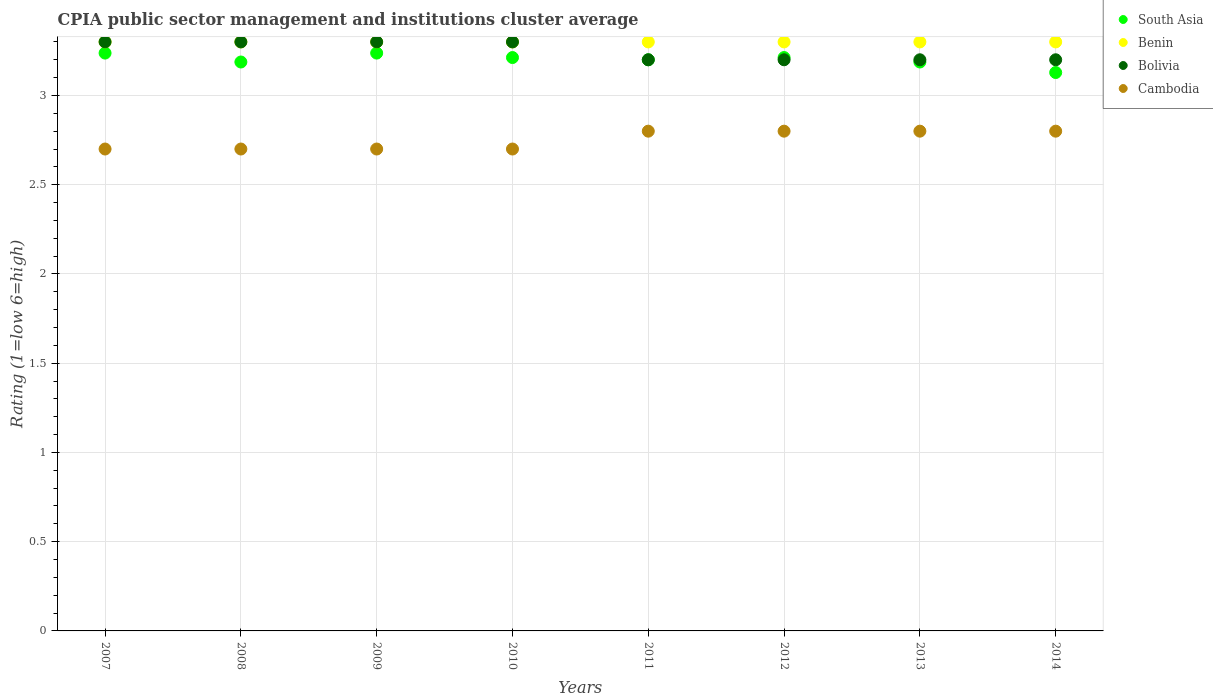How many different coloured dotlines are there?
Give a very brief answer. 4. Across all years, what is the minimum CPIA rating in Benin?
Offer a terse response. 3.3. What is the total CPIA rating in South Asia in the graph?
Give a very brief answer. 25.6. What is the difference between the CPIA rating in Bolivia in 2009 and that in 2012?
Your answer should be very brief. 0.1. What is the difference between the CPIA rating in Benin in 2009 and the CPIA rating in Cambodia in 2007?
Offer a very short reply. 0.6. What is the average CPIA rating in South Asia per year?
Ensure brevity in your answer.  3.2. In the year 2009, what is the difference between the CPIA rating in Cambodia and CPIA rating in South Asia?
Give a very brief answer. -0.54. In how many years, is the CPIA rating in Bolivia greater than 1.7?
Provide a short and direct response. 8. Is the difference between the CPIA rating in Cambodia in 2007 and 2010 greater than the difference between the CPIA rating in South Asia in 2007 and 2010?
Ensure brevity in your answer.  No. What is the difference between the highest and the second highest CPIA rating in South Asia?
Your response must be concise. 0. What is the difference between the highest and the lowest CPIA rating in Cambodia?
Give a very brief answer. 0.1. Is the CPIA rating in South Asia strictly greater than the CPIA rating in Bolivia over the years?
Offer a very short reply. No. Is the CPIA rating in Benin strictly less than the CPIA rating in Bolivia over the years?
Your answer should be very brief. No. How many years are there in the graph?
Provide a short and direct response. 8. Are the values on the major ticks of Y-axis written in scientific E-notation?
Ensure brevity in your answer.  No. Does the graph contain grids?
Your answer should be very brief. Yes. Where does the legend appear in the graph?
Offer a very short reply. Top right. What is the title of the graph?
Provide a succinct answer. CPIA public sector management and institutions cluster average. Does "Arab World" appear as one of the legend labels in the graph?
Your answer should be very brief. No. What is the label or title of the X-axis?
Keep it short and to the point. Years. What is the label or title of the Y-axis?
Your answer should be compact. Rating (1=low 6=high). What is the Rating (1=low 6=high) of South Asia in 2007?
Your answer should be very brief. 3.24. What is the Rating (1=low 6=high) of Bolivia in 2007?
Your response must be concise. 3.3. What is the Rating (1=low 6=high) of Cambodia in 2007?
Keep it short and to the point. 2.7. What is the Rating (1=low 6=high) in South Asia in 2008?
Ensure brevity in your answer.  3.19. What is the Rating (1=low 6=high) in Benin in 2008?
Your response must be concise. 3.3. What is the Rating (1=low 6=high) of South Asia in 2009?
Your response must be concise. 3.24. What is the Rating (1=low 6=high) of South Asia in 2010?
Keep it short and to the point. 3.21. What is the Rating (1=low 6=high) in Benin in 2010?
Make the answer very short. 3.3. What is the Rating (1=low 6=high) in Bolivia in 2010?
Your response must be concise. 3.3. What is the Rating (1=low 6=high) of Cambodia in 2010?
Provide a short and direct response. 2.7. What is the Rating (1=low 6=high) in South Asia in 2011?
Ensure brevity in your answer.  3.2. What is the Rating (1=low 6=high) of Benin in 2011?
Offer a very short reply. 3.3. What is the Rating (1=low 6=high) of Bolivia in 2011?
Provide a succinct answer. 3.2. What is the Rating (1=low 6=high) of South Asia in 2012?
Offer a terse response. 3.21. What is the Rating (1=low 6=high) in Cambodia in 2012?
Ensure brevity in your answer.  2.8. What is the Rating (1=low 6=high) of South Asia in 2013?
Your response must be concise. 3.19. What is the Rating (1=low 6=high) in Benin in 2013?
Ensure brevity in your answer.  3.3. What is the Rating (1=low 6=high) of Bolivia in 2013?
Keep it short and to the point. 3.2. What is the Rating (1=low 6=high) in Cambodia in 2013?
Your answer should be very brief. 2.8. What is the Rating (1=low 6=high) of South Asia in 2014?
Offer a terse response. 3.13. What is the Rating (1=low 6=high) of Benin in 2014?
Make the answer very short. 3.3. What is the Rating (1=low 6=high) of Bolivia in 2014?
Offer a terse response. 3.2. What is the Rating (1=low 6=high) of Cambodia in 2014?
Keep it short and to the point. 2.8. Across all years, what is the maximum Rating (1=low 6=high) of South Asia?
Your answer should be compact. 3.24. Across all years, what is the maximum Rating (1=low 6=high) in Bolivia?
Keep it short and to the point. 3.3. Across all years, what is the maximum Rating (1=low 6=high) in Cambodia?
Keep it short and to the point. 2.8. Across all years, what is the minimum Rating (1=low 6=high) of South Asia?
Your response must be concise. 3.13. Across all years, what is the minimum Rating (1=low 6=high) in Bolivia?
Your answer should be very brief. 3.2. What is the total Rating (1=low 6=high) in South Asia in the graph?
Give a very brief answer. 25.6. What is the total Rating (1=low 6=high) in Benin in the graph?
Give a very brief answer. 26.4. What is the total Rating (1=low 6=high) of Cambodia in the graph?
Your answer should be compact. 22. What is the difference between the Rating (1=low 6=high) in South Asia in 2007 and that in 2008?
Your response must be concise. 0.05. What is the difference between the Rating (1=low 6=high) in South Asia in 2007 and that in 2010?
Offer a very short reply. 0.03. What is the difference between the Rating (1=low 6=high) in Benin in 2007 and that in 2010?
Offer a very short reply. 0. What is the difference between the Rating (1=low 6=high) in South Asia in 2007 and that in 2011?
Your response must be concise. 0.04. What is the difference between the Rating (1=low 6=high) of Benin in 2007 and that in 2011?
Offer a very short reply. 0. What is the difference between the Rating (1=low 6=high) of Bolivia in 2007 and that in 2011?
Ensure brevity in your answer.  0.1. What is the difference between the Rating (1=low 6=high) in Cambodia in 2007 and that in 2011?
Your answer should be compact. -0.1. What is the difference between the Rating (1=low 6=high) in South Asia in 2007 and that in 2012?
Your answer should be compact. 0.03. What is the difference between the Rating (1=low 6=high) in Bolivia in 2007 and that in 2012?
Offer a very short reply. 0.1. What is the difference between the Rating (1=low 6=high) of South Asia in 2007 and that in 2013?
Your response must be concise. 0.05. What is the difference between the Rating (1=low 6=high) in Benin in 2007 and that in 2013?
Offer a very short reply. 0. What is the difference between the Rating (1=low 6=high) of Cambodia in 2007 and that in 2013?
Provide a succinct answer. -0.1. What is the difference between the Rating (1=low 6=high) of South Asia in 2007 and that in 2014?
Your answer should be very brief. 0.11. What is the difference between the Rating (1=low 6=high) in South Asia in 2008 and that in 2009?
Provide a short and direct response. -0.05. What is the difference between the Rating (1=low 6=high) of South Asia in 2008 and that in 2010?
Your response must be concise. -0.03. What is the difference between the Rating (1=low 6=high) in Benin in 2008 and that in 2010?
Provide a short and direct response. 0. What is the difference between the Rating (1=low 6=high) of Bolivia in 2008 and that in 2010?
Offer a terse response. 0. What is the difference between the Rating (1=low 6=high) of Cambodia in 2008 and that in 2010?
Offer a very short reply. 0. What is the difference between the Rating (1=low 6=high) in South Asia in 2008 and that in 2011?
Give a very brief answer. -0.01. What is the difference between the Rating (1=low 6=high) in Bolivia in 2008 and that in 2011?
Ensure brevity in your answer.  0.1. What is the difference between the Rating (1=low 6=high) in Cambodia in 2008 and that in 2011?
Your answer should be very brief. -0.1. What is the difference between the Rating (1=low 6=high) of South Asia in 2008 and that in 2012?
Provide a succinct answer. -0.03. What is the difference between the Rating (1=low 6=high) of Benin in 2008 and that in 2012?
Make the answer very short. 0. What is the difference between the Rating (1=low 6=high) of Bolivia in 2008 and that in 2012?
Make the answer very short. 0.1. What is the difference between the Rating (1=low 6=high) of Cambodia in 2008 and that in 2012?
Offer a very short reply. -0.1. What is the difference between the Rating (1=low 6=high) in South Asia in 2008 and that in 2013?
Your answer should be very brief. 0. What is the difference between the Rating (1=low 6=high) in Benin in 2008 and that in 2013?
Your response must be concise. 0. What is the difference between the Rating (1=low 6=high) of Bolivia in 2008 and that in 2013?
Your answer should be very brief. 0.1. What is the difference between the Rating (1=low 6=high) in Cambodia in 2008 and that in 2013?
Give a very brief answer. -0.1. What is the difference between the Rating (1=low 6=high) in South Asia in 2008 and that in 2014?
Make the answer very short. 0.06. What is the difference between the Rating (1=low 6=high) in South Asia in 2009 and that in 2010?
Offer a terse response. 0.03. What is the difference between the Rating (1=low 6=high) of Bolivia in 2009 and that in 2010?
Your response must be concise. 0. What is the difference between the Rating (1=low 6=high) of Cambodia in 2009 and that in 2010?
Ensure brevity in your answer.  0. What is the difference between the Rating (1=low 6=high) of South Asia in 2009 and that in 2011?
Offer a very short reply. 0.04. What is the difference between the Rating (1=low 6=high) of Bolivia in 2009 and that in 2011?
Your answer should be compact. 0.1. What is the difference between the Rating (1=low 6=high) in South Asia in 2009 and that in 2012?
Make the answer very short. 0.03. What is the difference between the Rating (1=low 6=high) of Bolivia in 2009 and that in 2012?
Offer a very short reply. 0.1. What is the difference between the Rating (1=low 6=high) in South Asia in 2009 and that in 2013?
Your answer should be very brief. 0.05. What is the difference between the Rating (1=low 6=high) in Bolivia in 2009 and that in 2013?
Provide a short and direct response. 0.1. What is the difference between the Rating (1=low 6=high) in South Asia in 2009 and that in 2014?
Keep it short and to the point. 0.11. What is the difference between the Rating (1=low 6=high) of Benin in 2009 and that in 2014?
Provide a succinct answer. 0. What is the difference between the Rating (1=low 6=high) of Bolivia in 2009 and that in 2014?
Ensure brevity in your answer.  0.1. What is the difference between the Rating (1=low 6=high) in Cambodia in 2009 and that in 2014?
Offer a terse response. -0.1. What is the difference between the Rating (1=low 6=high) of South Asia in 2010 and that in 2011?
Make the answer very short. 0.01. What is the difference between the Rating (1=low 6=high) of Benin in 2010 and that in 2011?
Offer a very short reply. 0. What is the difference between the Rating (1=low 6=high) in Cambodia in 2010 and that in 2011?
Provide a short and direct response. -0.1. What is the difference between the Rating (1=low 6=high) in South Asia in 2010 and that in 2012?
Provide a short and direct response. 0. What is the difference between the Rating (1=low 6=high) of Cambodia in 2010 and that in 2012?
Your answer should be very brief. -0.1. What is the difference between the Rating (1=low 6=high) of South Asia in 2010 and that in 2013?
Provide a short and direct response. 0.03. What is the difference between the Rating (1=low 6=high) of Bolivia in 2010 and that in 2013?
Provide a short and direct response. 0.1. What is the difference between the Rating (1=low 6=high) of Cambodia in 2010 and that in 2013?
Ensure brevity in your answer.  -0.1. What is the difference between the Rating (1=low 6=high) in South Asia in 2010 and that in 2014?
Offer a very short reply. 0.08. What is the difference between the Rating (1=low 6=high) in Benin in 2010 and that in 2014?
Your answer should be compact. 0. What is the difference between the Rating (1=low 6=high) in Bolivia in 2010 and that in 2014?
Provide a succinct answer. 0.1. What is the difference between the Rating (1=low 6=high) of Cambodia in 2010 and that in 2014?
Your answer should be very brief. -0.1. What is the difference between the Rating (1=low 6=high) in South Asia in 2011 and that in 2012?
Offer a terse response. -0.01. What is the difference between the Rating (1=low 6=high) of Benin in 2011 and that in 2012?
Keep it short and to the point. 0. What is the difference between the Rating (1=low 6=high) of South Asia in 2011 and that in 2013?
Keep it short and to the point. 0.01. What is the difference between the Rating (1=low 6=high) of Cambodia in 2011 and that in 2013?
Keep it short and to the point. 0. What is the difference between the Rating (1=low 6=high) in South Asia in 2011 and that in 2014?
Your answer should be very brief. 0.07. What is the difference between the Rating (1=low 6=high) of Bolivia in 2011 and that in 2014?
Give a very brief answer. 0. What is the difference between the Rating (1=low 6=high) in Cambodia in 2011 and that in 2014?
Provide a short and direct response. 0. What is the difference between the Rating (1=low 6=high) in South Asia in 2012 and that in 2013?
Your answer should be compact. 0.03. What is the difference between the Rating (1=low 6=high) of Bolivia in 2012 and that in 2013?
Provide a succinct answer. 0. What is the difference between the Rating (1=low 6=high) in South Asia in 2012 and that in 2014?
Your answer should be compact. 0.08. What is the difference between the Rating (1=low 6=high) in South Asia in 2013 and that in 2014?
Give a very brief answer. 0.06. What is the difference between the Rating (1=low 6=high) in Benin in 2013 and that in 2014?
Offer a very short reply. 0. What is the difference between the Rating (1=low 6=high) in Cambodia in 2013 and that in 2014?
Ensure brevity in your answer.  0. What is the difference between the Rating (1=low 6=high) in South Asia in 2007 and the Rating (1=low 6=high) in Benin in 2008?
Your answer should be compact. -0.06. What is the difference between the Rating (1=low 6=high) in South Asia in 2007 and the Rating (1=low 6=high) in Bolivia in 2008?
Your answer should be compact. -0.06. What is the difference between the Rating (1=low 6=high) of South Asia in 2007 and the Rating (1=low 6=high) of Cambodia in 2008?
Your answer should be compact. 0.54. What is the difference between the Rating (1=low 6=high) of Benin in 2007 and the Rating (1=low 6=high) of Cambodia in 2008?
Your answer should be very brief. 0.6. What is the difference between the Rating (1=low 6=high) in South Asia in 2007 and the Rating (1=low 6=high) in Benin in 2009?
Give a very brief answer. -0.06. What is the difference between the Rating (1=low 6=high) of South Asia in 2007 and the Rating (1=low 6=high) of Bolivia in 2009?
Provide a short and direct response. -0.06. What is the difference between the Rating (1=low 6=high) of South Asia in 2007 and the Rating (1=low 6=high) of Cambodia in 2009?
Offer a very short reply. 0.54. What is the difference between the Rating (1=low 6=high) in South Asia in 2007 and the Rating (1=low 6=high) in Benin in 2010?
Provide a succinct answer. -0.06. What is the difference between the Rating (1=low 6=high) in South Asia in 2007 and the Rating (1=low 6=high) in Bolivia in 2010?
Provide a succinct answer. -0.06. What is the difference between the Rating (1=low 6=high) in South Asia in 2007 and the Rating (1=low 6=high) in Cambodia in 2010?
Your response must be concise. 0.54. What is the difference between the Rating (1=low 6=high) of Benin in 2007 and the Rating (1=low 6=high) of Cambodia in 2010?
Offer a terse response. 0.6. What is the difference between the Rating (1=low 6=high) of South Asia in 2007 and the Rating (1=low 6=high) of Benin in 2011?
Your answer should be compact. -0.06. What is the difference between the Rating (1=low 6=high) of South Asia in 2007 and the Rating (1=low 6=high) of Bolivia in 2011?
Offer a very short reply. 0.04. What is the difference between the Rating (1=low 6=high) of South Asia in 2007 and the Rating (1=low 6=high) of Cambodia in 2011?
Make the answer very short. 0.44. What is the difference between the Rating (1=low 6=high) in Bolivia in 2007 and the Rating (1=low 6=high) in Cambodia in 2011?
Provide a short and direct response. 0.5. What is the difference between the Rating (1=low 6=high) in South Asia in 2007 and the Rating (1=low 6=high) in Benin in 2012?
Offer a very short reply. -0.06. What is the difference between the Rating (1=low 6=high) in South Asia in 2007 and the Rating (1=low 6=high) in Bolivia in 2012?
Your response must be concise. 0.04. What is the difference between the Rating (1=low 6=high) in South Asia in 2007 and the Rating (1=low 6=high) in Cambodia in 2012?
Offer a terse response. 0.44. What is the difference between the Rating (1=low 6=high) of Benin in 2007 and the Rating (1=low 6=high) of Bolivia in 2012?
Ensure brevity in your answer.  0.1. What is the difference between the Rating (1=low 6=high) in Bolivia in 2007 and the Rating (1=low 6=high) in Cambodia in 2012?
Offer a terse response. 0.5. What is the difference between the Rating (1=low 6=high) in South Asia in 2007 and the Rating (1=low 6=high) in Benin in 2013?
Keep it short and to the point. -0.06. What is the difference between the Rating (1=low 6=high) in South Asia in 2007 and the Rating (1=low 6=high) in Bolivia in 2013?
Offer a terse response. 0.04. What is the difference between the Rating (1=low 6=high) in South Asia in 2007 and the Rating (1=low 6=high) in Cambodia in 2013?
Ensure brevity in your answer.  0.44. What is the difference between the Rating (1=low 6=high) of Benin in 2007 and the Rating (1=low 6=high) of Bolivia in 2013?
Your answer should be compact. 0.1. What is the difference between the Rating (1=low 6=high) of South Asia in 2007 and the Rating (1=low 6=high) of Benin in 2014?
Offer a terse response. -0.06. What is the difference between the Rating (1=low 6=high) of South Asia in 2007 and the Rating (1=low 6=high) of Bolivia in 2014?
Offer a terse response. 0.04. What is the difference between the Rating (1=low 6=high) in South Asia in 2007 and the Rating (1=low 6=high) in Cambodia in 2014?
Ensure brevity in your answer.  0.44. What is the difference between the Rating (1=low 6=high) of Benin in 2007 and the Rating (1=low 6=high) of Bolivia in 2014?
Ensure brevity in your answer.  0.1. What is the difference between the Rating (1=low 6=high) of South Asia in 2008 and the Rating (1=low 6=high) of Benin in 2009?
Provide a short and direct response. -0.11. What is the difference between the Rating (1=low 6=high) of South Asia in 2008 and the Rating (1=low 6=high) of Bolivia in 2009?
Provide a short and direct response. -0.11. What is the difference between the Rating (1=low 6=high) of South Asia in 2008 and the Rating (1=low 6=high) of Cambodia in 2009?
Offer a very short reply. 0.49. What is the difference between the Rating (1=low 6=high) of Bolivia in 2008 and the Rating (1=low 6=high) of Cambodia in 2009?
Offer a very short reply. 0.6. What is the difference between the Rating (1=low 6=high) in South Asia in 2008 and the Rating (1=low 6=high) in Benin in 2010?
Make the answer very short. -0.11. What is the difference between the Rating (1=low 6=high) of South Asia in 2008 and the Rating (1=low 6=high) of Bolivia in 2010?
Make the answer very short. -0.11. What is the difference between the Rating (1=low 6=high) of South Asia in 2008 and the Rating (1=low 6=high) of Cambodia in 2010?
Your response must be concise. 0.49. What is the difference between the Rating (1=low 6=high) in Benin in 2008 and the Rating (1=low 6=high) in Cambodia in 2010?
Keep it short and to the point. 0.6. What is the difference between the Rating (1=low 6=high) in Bolivia in 2008 and the Rating (1=low 6=high) in Cambodia in 2010?
Provide a short and direct response. 0.6. What is the difference between the Rating (1=low 6=high) in South Asia in 2008 and the Rating (1=low 6=high) in Benin in 2011?
Offer a terse response. -0.11. What is the difference between the Rating (1=low 6=high) of South Asia in 2008 and the Rating (1=low 6=high) of Bolivia in 2011?
Offer a terse response. -0.01. What is the difference between the Rating (1=low 6=high) of South Asia in 2008 and the Rating (1=low 6=high) of Cambodia in 2011?
Provide a succinct answer. 0.39. What is the difference between the Rating (1=low 6=high) in Benin in 2008 and the Rating (1=low 6=high) in Cambodia in 2011?
Give a very brief answer. 0.5. What is the difference between the Rating (1=low 6=high) of South Asia in 2008 and the Rating (1=low 6=high) of Benin in 2012?
Make the answer very short. -0.11. What is the difference between the Rating (1=low 6=high) in South Asia in 2008 and the Rating (1=low 6=high) in Bolivia in 2012?
Your response must be concise. -0.01. What is the difference between the Rating (1=low 6=high) of South Asia in 2008 and the Rating (1=low 6=high) of Cambodia in 2012?
Keep it short and to the point. 0.39. What is the difference between the Rating (1=low 6=high) of South Asia in 2008 and the Rating (1=low 6=high) of Benin in 2013?
Provide a succinct answer. -0.11. What is the difference between the Rating (1=low 6=high) in South Asia in 2008 and the Rating (1=low 6=high) in Bolivia in 2013?
Provide a succinct answer. -0.01. What is the difference between the Rating (1=low 6=high) in South Asia in 2008 and the Rating (1=low 6=high) in Cambodia in 2013?
Offer a terse response. 0.39. What is the difference between the Rating (1=low 6=high) of Benin in 2008 and the Rating (1=low 6=high) of Bolivia in 2013?
Give a very brief answer. 0.1. What is the difference between the Rating (1=low 6=high) in Benin in 2008 and the Rating (1=low 6=high) in Cambodia in 2013?
Offer a terse response. 0.5. What is the difference between the Rating (1=low 6=high) of South Asia in 2008 and the Rating (1=low 6=high) of Benin in 2014?
Offer a terse response. -0.11. What is the difference between the Rating (1=low 6=high) of South Asia in 2008 and the Rating (1=low 6=high) of Bolivia in 2014?
Your answer should be very brief. -0.01. What is the difference between the Rating (1=low 6=high) in South Asia in 2008 and the Rating (1=low 6=high) in Cambodia in 2014?
Offer a very short reply. 0.39. What is the difference between the Rating (1=low 6=high) of Benin in 2008 and the Rating (1=low 6=high) of Bolivia in 2014?
Your response must be concise. 0.1. What is the difference between the Rating (1=low 6=high) of Benin in 2008 and the Rating (1=low 6=high) of Cambodia in 2014?
Your response must be concise. 0.5. What is the difference between the Rating (1=low 6=high) of Bolivia in 2008 and the Rating (1=low 6=high) of Cambodia in 2014?
Provide a short and direct response. 0.5. What is the difference between the Rating (1=low 6=high) of South Asia in 2009 and the Rating (1=low 6=high) of Benin in 2010?
Give a very brief answer. -0.06. What is the difference between the Rating (1=low 6=high) of South Asia in 2009 and the Rating (1=low 6=high) of Bolivia in 2010?
Make the answer very short. -0.06. What is the difference between the Rating (1=low 6=high) in South Asia in 2009 and the Rating (1=low 6=high) in Cambodia in 2010?
Offer a very short reply. 0.54. What is the difference between the Rating (1=low 6=high) of Benin in 2009 and the Rating (1=low 6=high) of Cambodia in 2010?
Provide a succinct answer. 0.6. What is the difference between the Rating (1=low 6=high) in Bolivia in 2009 and the Rating (1=low 6=high) in Cambodia in 2010?
Ensure brevity in your answer.  0.6. What is the difference between the Rating (1=low 6=high) in South Asia in 2009 and the Rating (1=low 6=high) in Benin in 2011?
Your answer should be very brief. -0.06. What is the difference between the Rating (1=low 6=high) in South Asia in 2009 and the Rating (1=low 6=high) in Bolivia in 2011?
Keep it short and to the point. 0.04. What is the difference between the Rating (1=low 6=high) of South Asia in 2009 and the Rating (1=low 6=high) of Cambodia in 2011?
Offer a terse response. 0.44. What is the difference between the Rating (1=low 6=high) of South Asia in 2009 and the Rating (1=low 6=high) of Benin in 2012?
Your response must be concise. -0.06. What is the difference between the Rating (1=low 6=high) of South Asia in 2009 and the Rating (1=low 6=high) of Bolivia in 2012?
Offer a terse response. 0.04. What is the difference between the Rating (1=low 6=high) in South Asia in 2009 and the Rating (1=low 6=high) in Cambodia in 2012?
Give a very brief answer. 0.44. What is the difference between the Rating (1=low 6=high) in South Asia in 2009 and the Rating (1=low 6=high) in Benin in 2013?
Offer a very short reply. -0.06. What is the difference between the Rating (1=low 6=high) of South Asia in 2009 and the Rating (1=low 6=high) of Bolivia in 2013?
Provide a short and direct response. 0.04. What is the difference between the Rating (1=low 6=high) of South Asia in 2009 and the Rating (1=low 6=high) of Cambodia in 2013?
Ensure brevity in your answer.  0.44. What is the difference between the Rating (1=low 6=high) in Benin in 2009 and the Rating (1=low 6=high) in Cambodia in 2013?
Offer a very short reply. 0.5. What is the difference between the Rating (1=low 6=high) of Bolivia in 2009 and the Rating (1=low 6=high) of Cambodia in 2013?
Keep it short and to the point. 0.5. What is the difference between the Rating (1=low 6=high) of South Asia in 2009 and the Rating (1=low 6=high) of Benin in 2014?
Your answer should be compact. -0.06. What is the difference between the Rating (1=low 6=high) in South Asia in 2009 and the Rating (1=low 6=high) in Bolivia in 2014?
Keep it short and to the point. 0.04. What is the difference between the Rating (1=low 6=high) of South Asia in 2009 and the Rating (1=low 6=high) of Cambodia in 2014?
Your answer should be compact. 0.44. What is the difference between the Rating (1=low 6=high) in Bolivia in 2009 and the Rating (1=low 6=high) in Cambodia in 2014?
Provide a short and direct response. 0.5. What is the difference between the Rating (1=low 6=high) in South Asia in 2010 and the Rating (1=low 6=high) in Benin in 2011?
Offer a terse response. -0.09. What is the difference between the Rating (1=low 6=high) of South Asia in 2010 and the Rating (1=low 6=high) of Bolivia in 2011?
Keep it short and to the point. 0.01. What is the difference between the Rating (1=low 6=high) of South Asia in 2010 and the Rating (1=low 6=high) of Cambodia in 2011?
Your answer should be very brief. 0.41. What is the difference between the Rating (1=low 6=high) of Benin in 2010 and the Rating (1=low 6=high) of Bolivia in 2011?
Give a very brief answer. 0.1. What is the difference between the Rating (1=low 6=high) of Bolivia in 2010 and the Rating (1=low 6=high) of Cambodia in 2011?
Your answer should be compact. 0.5. What is the difference between the Rating (1=low 6=high) of South Asia in 2010 and the Rating (1=low 6=high) of Benin in 2012?
Offer a terse response. -0.09. What is the difference between the Rating (1=low 6=high) in South Asia in 2010 and the Rating (1=low 6=high) in Bolivia in 2012?
Your answer should be compact. 0.01. What is the difference between the Rating (1=low 6=high) in South Asia in 2010 and the Rating (1=low 6=high) in Cambodia in 2012?
Provide a succinct answer. 0.41. What is the difference between the Rating (1=low 6=high) in Bolivia in 2010 and the Rating (1=low 6=high) in Cambodia in 2012?
Your answer should be very brief. 0.5. What is the difference between the Rating (1=low 6=high) in South Asia in 2010 and the Rating (1=low 6=high) in Benin in 2013?
Ensure brevity in your answer.  -0.09. What is the difference between the Rating (1=low 6=high) of South Asia in 2010 and the Rating (1=low 6=high) of Bolivia in 2013?
Your answer should be compact. 0.01. What is the difference between the Rating (1=low 6=high) of South Asia in 2010 and the Rating (1=low 6=high) of Cambodia in 2013?
Provide a short and direct response. 0.41. What is the difference between the Rating (1=low 6=high) in Benin in 2010 and the Rating (1=low 6=high) in Bolivia in 2013?
Ensure brevity in your answer.  0.1. What is the difference between the Rating (1=low 6=high) in Benin in 2010 and the Rating (1=low 6=high) in Cambodia in 2013?
Your response must be concise. 0.5. What is the difference between the Rating (1=low 6=high) of South Asia in 2010 and the Rating (1=low 6=high) of Benin in 2014?
Give a very brief answer. -0.09. What is the difference between the Rating (1=low 6=high) in South Asia in 2010 and the Rating (1=low 6=high) in Bolivia in 2014?
Your answer should be compact. 0.01. What is the difference between the Rating (1=low 6=high) in South Asia in 2010 and the Rating (1=low 6=high) in Cambodia in 2014?
Your answer should be compact. 0.41. What is the difference between the Rating (1=low 6=high) in Benin in 2010 and the Rating (1=low 6=high) in Cambodia in 2014?
Offer a terse response. 0.5. What is the difference between the Rating (1=low 6=high) in Bolivia in 2010 and the Rating (1=low 6=high) in Cambodia in 2014?
Offer a very short reply. 0.5. What is the difference between the Rating (1=low 6=high) in South Asia in 2011 and the Rating (1=low 6=high) in Benin in 2012?
Offer a terse response. -0.1. What is the difference between the Rating (1=low 6=high) of South Asia in 2011 and the Rating (1=low 6=high) of Bolivia in 2012?
Your response must be concise. 0. What is the difference between the Rating (1=low 6=high) of Benin in 2011 and the Rating (1=low 6=high) of Cambodia in 2012?
Your response must be concise. 0.5. What is the difference between the Rating (1=low 6=high) of Bolivia in 2011 and the Rating (1=low 6=high) of Cambodia in 2012?
Offer a very short reply. 0.4. What is the difference between the Rating (1=low 6=high) of South Asia in 2011 and the Rating (1=low 6=high) of Benin in 2013?
Your response must be concise. -0.1. What is the difference between the Rating (1=low 6=high) in South Asia in 2011 and the Rating (1=low 6=high) in Bolivia in 2013?
Ensure brevity in your answer.  0. What is the difference between the Rating (1=low 6=high) in South Asia in 2011 and the Rating (1=low 6=high) in Cambodia in 2013?
Make the answer very short. 0.4. What is the difference between the Rating (1=low 6=high) of Benin in 2011 and the Rating (1=low 6=high) of Bolivia in 2013?
Your answer should be very brief. 0.1. What is the difference between the Rating (1=low 6=high) in South Asia in 2011 and the Rating (1=low 6=high) in Benin in 2014?
Give a very brief answer. -0.1. What is the difference between the Rating (1=low 6=high) in South Asia in 2011 and the Rating (1=low 6=high) in Bolivia in 2014?
Give a very brief answer. 0. What is the difference between the Rating (1=low 6=high) in Benin in 2011 and the Rating (1=low 6=high) in Bolivia in 2014?
Provide a succinct answer. 0.1. What is the difference between the Rating (1=low 6=high) of Benin in 2011 and the Rating (1=low 6=high) of Cambodia in 2014?
Provide a short and direct response. 0.5. What is the difference between the Rating (1=low 6=high) in South Asia in 2012 and the Rating (1=low 6=high) in Benin in 2013?
Ensure brevity in your answer.  -0.09. What is the difference between the Rating (1=low 6=high) of South Asia in 2012 and the Rating (1=low 6=high) of Bolivia in 2013?
Your answer should be compact. 0.01. What is the difference between the Rating (1=low 6=high) of South Asia in 2012 and the Rating (1=low 6=high) of Cambodia in 2013?
Ensure brevity in your answer.  0.41. What is the difference between the Rating (1=low 6=high) of Benin in 2012 and the Rating (1=low 6=high) of Bolivia in 2013?
Keep it short and to the point. 0.1. What is the difference between the Rating (1=low 6=high) in South Asia in 2012 and the Rating (1=low 6=high) in Benin in 2014?
Provide a succinct answer. -0.09. What is the difference between the Rating (1=low 6=high) of South Asia in 2012 and the Rating (1=low 6=high) of Bolivia in 2014?
Provide a succinct answer. 0.01. What is the difference between the Rating (1=low 6=high) of South Asia in 2012 and the Rating (1=low 6=high) of Cambodia in 2014?
Ensure brevity in your answer.  0.41. What is the difference between the Rating (1=low 6=high) of Benin in 2012 and the Rating (1=low 6=high) of Bolivia in 2014?
Your answer should be compact. 0.1. What is the difference between the Rating (1=low 6=high) of South Asia in 2013 and the Rating (1=low 6=high) of Benin in 2014?
Ensure brevity in your answer.  -0.11. What is the difference between the Rating (1=low 6=high) in South Asia in 2013 and the Rating (1=low 6=high) in Bolivia in 2014?
Ensure brevity in your answer.  -0.01. What is the difference between the Rating (1=low 6=high) in South Asia in 2013 and the Rating (1=low 6=high) in Cambodia in 2014?
Your answer should be very brief. 0.39. What is the difference between the Rating (1=low 6=high) of Benin in 2013 and the Rating (1=low 6=high) of Cambodia in 2014?
Ensure brevity in your answer.  0.5. What is the difference between the Rating (1=low 6=high) of Bolivia in 2013 and the Rating (1=low 6=high) of Cambodia in 2014?
Your answer should be very brief. 0.4. What is the average Rating (1=low 6=high) of South Asia per year?
Ensure brevity in your answer.  3.2. What is the average Rating (1=low 6=high) of Bolivia per year?
Offer a very short reply. 3.25. What is the average Rating (1=low 6=high) of Cambodia per year?
Your answer should be very brief. 2.75. In the year 2007, what is the difference between the Rating (1=low 6=high) of South Asia and Rating (1=low 6=high) of Benin?
Your response must be concise. -0.06. In the year 2007, what is the difference between the Rating (1=low 6=high) of South Asia and Rating (1=low 6=high) of Bolivia?
Provide a short and direct response. -0.06. In the year 2007, what is the difference between the Rating (1=low 6=high) of South Asia and Rating (1=low 6=high) of Cambodia?
Provide a short and direct response. 0.54. In the year 2007, what is the difference between the Rating (1=low 6=high) of Benin and Rating (1=low 6=high) of Bolivia?
Your response must be concise. 0. In the year 2007, what is the difference between the Rating (1=low 6=high) in Bolivia and Rating (1=low 6=high) in Cambodia?
Give a very brief answer. 0.6. In the year 2008, what is the difference between the Rating (1=low 6=high) in South Asia and Rating (1=low 6=high) in Benin?
Offer a terse response. -0.11. In the year 2008, what is the difference between the Rating (1=low 6=high) in South Asia and Rating (1=low 6=high) in Bolivia?
Offer a very short reply. -0.11. In the year 2008, what is the difference between the Rating (1=low 6=high) of South Asia and Rating (1=low 6=high) of Cambodia?
Your response must be concise. 0.49. In the year 2008, what is the difference between the Rating (1=low 6=high) in Benin and Rating (1=low 6=high) in Cambodia?
Make the answer very short. 0.6. In the year 2009, what is the difference between the Rating (1=low 6=high) in South Asia and Rating (1=low 6=high) in Benin?
Offer a terse response. -0.06. In the year 2009, what is the difference between the Rating (1=low 6=high) of South Asia and Rating (1=low 6=high) of Bolivia?
Your response must be concise. -0.06. In the year 2009, what is the difference between the Rating (1=low 6=high) in South Asia and Rating (1=low 6=high) in Cambodia?
Your response must be concise. 0.54. In the year 2009, what is the difference between the Rating (1=low 6=high) in Benin and Rating (1=low 6=high) in Cambodia?
Keep it short and to the point. 0.6. In the year 2010, what is the difference between the Rating (1=low 6=high) in South Asia and Rating (1=low 6=high) in Benin?
Provide a short and direct response. -0.09. In the year 2010, what is the difference between the Rating (1=low 6=high) of South Asia and Rating (1=low 6=high) of Bolivia?
Ensure brevity in your answer.  -0.09. In the year 2010, what is the difference between the Rating (1=low 6=high) in South Asia and Rating (1=low 6=high) in Cambodia?
Offer a very short reply. 0.51. In the year 2010, what is the difference between the Rating (1=low 6=high) in Benin and Rating (1=low 6=high) in Bolivia?
Offer a terse response. 0. In the year 2010, what is the difference between the Rating (1=low 6=high) in Benin and Rating (1=low 6=high) in Cambodia?
Ensure brevity in your answer.  0.6. In the year 2010, what is the difference between the Rating (1=low 6=high) in Bolivia and Rating (1=low 6=high) in Cambodia?
Your answer should be compact. 0.6. In the year 2011, what is the difference between the Rating (1=low 6=high) of South Asia and Rating (1=low 6=high) of Benin?
Keep it short and to the point. -0.1. In the year 2011, what is the difference between the Rating (1=low 6=high) of Benin and Rating (1=low 6=high) of Bolivia?
Offer a very short reply. 0.1. In the year 2012, what is the difference between the Rating (1=low 6=high) in South Asia and Rating (1=low 6=high) in Benin?
Provide a short and direct response. -0.09. In the year 2012, what is the difference between the Rating (1=low 6=high) of South Asia and Rating (1=low 6=high) of Bolivia?
Make the answer very short. 0.01. In the year 2012, what is the difference between the Rating (1=low 6=high) in South Asia and Rating (1=low 6=high) in Cambodia?
Give a very brief answer. 0.41. In the year 2012, what is the difference between the Rating (1=low 6=high) in Benin and Rating (1=low 6=high) in Cambodia?
Your answer should be very brief. 0.5. In the year 2013, what is the difference between the Rating (1=low 6=high) in South Asia and Rating (1=low 6=high) in Benin?
Your response must be concise. -0.11. In the year 2013, what is the difference between the Rating (1=low 6=high) of South Asia and Rating (1=low 6=high) of Bolivia?
Provide a succinct answer. -0.01. In the year 2013, what is the difference between the Rating (1=low 6=high) in South Asia and Rating (1=low 6=high) in Cambodia?
Your response must be concise. 0.39. In the year 2013, what is the difference between the Rating (1=low 6=high) in Benin and Rating (1=low 6=high) in Bolivia?
Offer a very short reply. 0.1. In the year 2013, what is the difference between the Rating (1=low 6=high) of Benin and Rating (1=low 6=high) of Cambodia?
Offer a terse response. 0.5. In the year 2013, what is the difference between the Rating (1=low 6=high) in Bolivia and Rating (1=low 6=high) in Cambodia?
Provide a short and direct response. 0.4. In the year 2014, what is the difference between the Rating (1=low 6=high) in South Asia and Rating (1=low 6=high) in Benin?
Your response must be concise. -0.17. In the year 2014, what is the difference between the Rating (1=low 6=high) in South Asia and Rating (1=low 6=high) in Bolivia?
Give a very brief answer. -0.07. In the year 2014, what is the difference between the Rating (1=low 6=high) of South Asia and Rating (1=low 6=high) of Cambodia?
Offer a very short reply. 0.33. In the year 2014, what is the difference between the Rating (1=low 6=high) of Benin and Rating (1=low 6=high) of Cambodia?
Keep it short and to the point. 0.5. What is the ratio of the Rating (1=low 6=high) in South Asia in 2007 to that in 2008?
Ensure brevity in your answer.  1.02. What is the ratio of the Rating (1=low 6=high) of Benin in 2007 to that in 2008?
Ensure brevity in your answer.  1. What is the ratio of the Rating (1=low 6=high) of Bolivia in 2007 to that in 2008?
Provide a succinct answer. 1. What is the ratio of the Rating (1=low 6=high) in Cambodia in 2007 to that in 2008?
Offer a terse response. 1. What is the ratio of the Rating (1=low 6=high) in Bolivia in 2007 to that in 2009?
Provide a short and direct response. 1. What is the ratio of the Rating (1=low 6=high) of Cambodia in 2007 to that in 2009?
Provide a short and direct response. 1. What is the ratio of the Rating (1=low 6=high) of South Asia in 2007 to that in 2010?
Ensure brevity in your answer.  1.01. What is the ratio of the Rating (1=low 6=high) in Cambodia in 2007 to that in 2010?
Ensure brevity in your answer.  1. What is the ratio of the Rating (1=low 6=high) in South Asia in 2007 to that in 2011?
Your answer should be very brief. 1.01. What is the ratio of the Rating (1=low 6=high) of Benin in 2007 to that in 2011?
Offer a terse response. 1. What is the ratio of the Rating (1=low 6=high) of Bolivia in 2007 to that in 2011?
Make the answer very short. 1.03. What is the ratio of the Rating (1=low 6=high) of Cambodia in 2007 to that in 2011?
Your answer should be very brief. 0.96. What is the ratio of the Rating (1=low 6=high) of South Asia in 2007 to that in 2012?
Your answer should be very brief. 1.01. What is the ratio of the Rating (1=low 6=high) of Bolivia in 2007 to that in 2012?
Give a very brief answer. 1.03. What is the ratio of the Rating (1=low 6=high) of South Asia in 2007 to that in 2013?
Provide a short and direct response. 1.02. What is the ratio of the Rating (1=low 6=high) in Benin in 2007 to that in 2013?
Your response must be concise. 1. What is the ratio of the Rating (1=low 6=high) in Bolivia in 2007 to that in 2013?
Keep it short and to the point. 1.03. What is the ratio of the Rating (1=low 6=high) of South Asia in 2007 to that in 2014?
Ensure brevity in your answer.  1.03. What is the ratio of the Rating (1=low 6=high) of Benin in 2007 to that in 2014?
Provide a short and direct response. 1. What is the ratio of the Rating (1=low 6=high) in Bolivia in 2007 to that in 2014?
Keep it short and to the point. 1.03. What is the ratio of the Rating (1=low 6=high) in Cambodia in 2007 to that in 2014?
Your answer should be very brief. 0.96. What is the ratio of the Rating (1=low 6=high) in South Asia in 2008 to that in 2009?
Offer a terse response. 0.98. What is the ratio of the Rating (1=low 6=high) in Cambodia in 2008 to that in 2009?
Give a very brief answer. 1. What is the ratio of the Rating (1=low 6=high) in Benin in 2008 to that in 2010?
Keep it short and to the point. 1. What is the ratio of the Rating (1=low 6=high) of Bolivia in 2008 to that in 2010?
Your answer should be very brief. 1. What is the ratio of the Rating (1=low 6=high) of Cambodia in 2008 to that in 2010?
Offer a very short reply. 1. What is the ratio of the Rating (1=low 6=high) in South Asia in 2008 to that in 2011?
Your answer should be very brief. 1. What is the ratio of the Rating (1=low 6=high) of Benin in 2008 to that in 2011?
Your response must be concise. 1. What is the ratio of the Rating (1=low 6=high) in Bolivia in 2008 to that in 2011?
Your answer should be very brief. 1.03. What is the ratio of the Rating (1=low 6=high) of Benin in 2008 to that in 2012?
Keep it short and to the point. 1. What is the ratio of the Rating (1=low 6=high) of Bolivia in 2008 to that in 2012?
Offer a very short reply. 1.03. What is the ratio of the Rating (1=low 6=high) in Cambodia in 2008 to that in 2012?
Offer a very short reply. 0.96. What is the ratio of the Rating (1=low 6=high) in South Asia in 2008 to that in 2013?
Provide a succinct answer. 1. What is the ratio of the Rating (1=low 6=high) in Bolivia in 2008 to that in 2013?
Provide a short and direct response. 1.03. What is the ratio of the Rating (1=low 6=high) of South Asia in 2008 to that in 2014?
Provide a succinct answer. 1.02. What is the ratio of the Rating (1=low 6=high) in Benin in 2008 to that in 2014?
Make the answer very short. 1. What is the ratio of the Rating (1=low 6=high) in Bolivia in 2008 to that in 2014?
Keep it short and to the point. 1.03. What is the ratio of the Rating (1=low 6=high) in South Asia in 2009 to that in 2010?
Provide a succinct answer. 1.01. What is the ratio of the Rating (1=low 6=high) of Bolivia in 2009 to that in 2010?
Offer a terse response. 1. What is the ratio of the Rating (1=low 6=high) in South Asia in 2009 to that in 2011?
Give a very brief answer. 1.01. What is the ratio of the Rating (1=low 6=high) of Benin in 2009 to that in 2011?
Keep it short and to the point. 1. What is the ratio of the Rating (1=low 6=high) of Bolivia in 2009 to that in 2011?
Provide a short and direct response. 1.03. What is the ratio of the Rating (1=low 6=high) in Cambodia in 2009 to that in 2011?
Offer a very short reply. 0.96. What is the ratio of the Rating (1=low 6=high) in South Asia in 2009 to that in 2012?
Ensure brevity in your answer.  1.01. What is the ratio of the Rating (1=low 6=high) of Benin in 2009 to that in 2012?
Offer a very short reply. 1. What is the ratio of the Rating (1=low 6=high) in Bolivia in 2009 to that in 2012?
Keep it short and to the point. 1.03. What is the ratio of the Rating (1=low 6=high) in South Asia in 2009 to that in 2013?
Offer a very short reply. 1.02. What is the ratio of the Rating (1=low 6=high) of Benin in 2009 to that in 2013?
Keep it short and to the point. 1. What is the ratio of the Rating (1=low 6=high) of Bolivia in 2009 to that in 2013?
Your answer should be compact. 1.03. What is the ratio of the Rating (1=low 6=high) of South Asia in 2009 to that in 2014?
Offer a terse response. 1.03. What is the ratio of the Rating (1=low 6=high) in Benin in 2009 to that in 2014?
Ensure brevity in your answer.  1. What is the ratio of the Rating (1=low 6=high) in Bolivia in 2009 to that in 2014?
Provide a short and direct response. 1.03. What is the ratio of the Rating (1=low 6=high) in Cambodia in 2009 to that in 2014?
Provide a succinct answer. 0.96. What is the ratio of the Rating (1=low 6=high) in South Asia in 2010 to that in 2011?
Offer a very short reply. 1. What is the ratio of the Rating (1=low 6=high) of Bolivia in 2010 to that in 2011?
Provide a short and direct response. 1.03. What is the ratio of the Rating (1=low 6=high) in Bolivia in 2010 to that in 2012?
Keep it short and to the point. 1.03. What is the ratio of the Rating (1=low 6=high) of Bolivia in 2010 to that in 2013?
Provide a succinct answer. 1.03. What is the ratio of the Rating (1=low 6=high) of South Asia in 2010 to that in 2014?
Provide a short and direct response. 1.03. What is the ratio of the Rating (1=low 6=high) in Benin in 2010 to that in 2014?
Provide a succinct answer. 1. What is the ratio of the Rating (1=low 6=high) in Bolivia in 2010 to that in 2014?
Your answer should be compact. 1.03. What is the ratio of the Rating (1=low 6=high) in South Asia in 2011 to that in 2012?
Make the answer very short. 1. What is the ratio of the Rating (1=low 6=high) in Benin in 2011 to that in 2012?
Ensure brevity in your answer.  1. What is the ratio of the Rating (1=low 6=high) in Cambodia in 2011 to that in 2012?
Your answer should be compact. 1. What is the ratio of the Rating (1=low 6=high) in Cambodia in 2011 to that in 2013?
Provide a succinct answer. 1. What is the ratio of the Rating (1=low 6=high) of South Asia in 2011 to that in 2014?
Provide a short and direct response. 1.02. What is the ratio of the Rating (1=low 6=high) of Cambodia in 2011 to that in 2014?
Provide a short and direct response. 1. What is the ratio of the Rating (1=low 6=high) of Benin in 2012 to that in 2013?
Offer a very short reply. 1. What is the ratio of the Rating (1=low 6=high) of Cambodia in 2012 to that in 2013?
Your answer should be compact. 1. What is the ratio of the Rating (1=low 6=high) in South Asia in 2012 to that in 2014?
Offer a terse response. 1.03. What is the ratio of the Rating (1=low 6=high) of Benin in 2012 to that in 2014?
Make the answer very short. 1. What is the ratio of the Rating (1=low 6=high) in South Asia in 2013 to that in 2014?
Provide a short and direct response. 1.02. What is the ratio of the Rating (1=low 6=high) in Bolivia in 2013 to that in 2014?
Your answer should be compact. 1. What is the ratio of the Rating (1=low 6=high) of Cambodia in 2013 to that in 2014?
Offer a terse response. 1. What is the difference between the highest and the second highest Rating (1=low 6=high) of Cambodia?
Provide a succinct answer. 0. What is the difference between the highest and the lowest Rating (1=low 6=high) of South Asia?
Offer a very short reply. 0.11. What is the difference between the highest and the lowest Rating (1=low 6=high) of Bolivia?
Your answer should be compact. 0.1. 